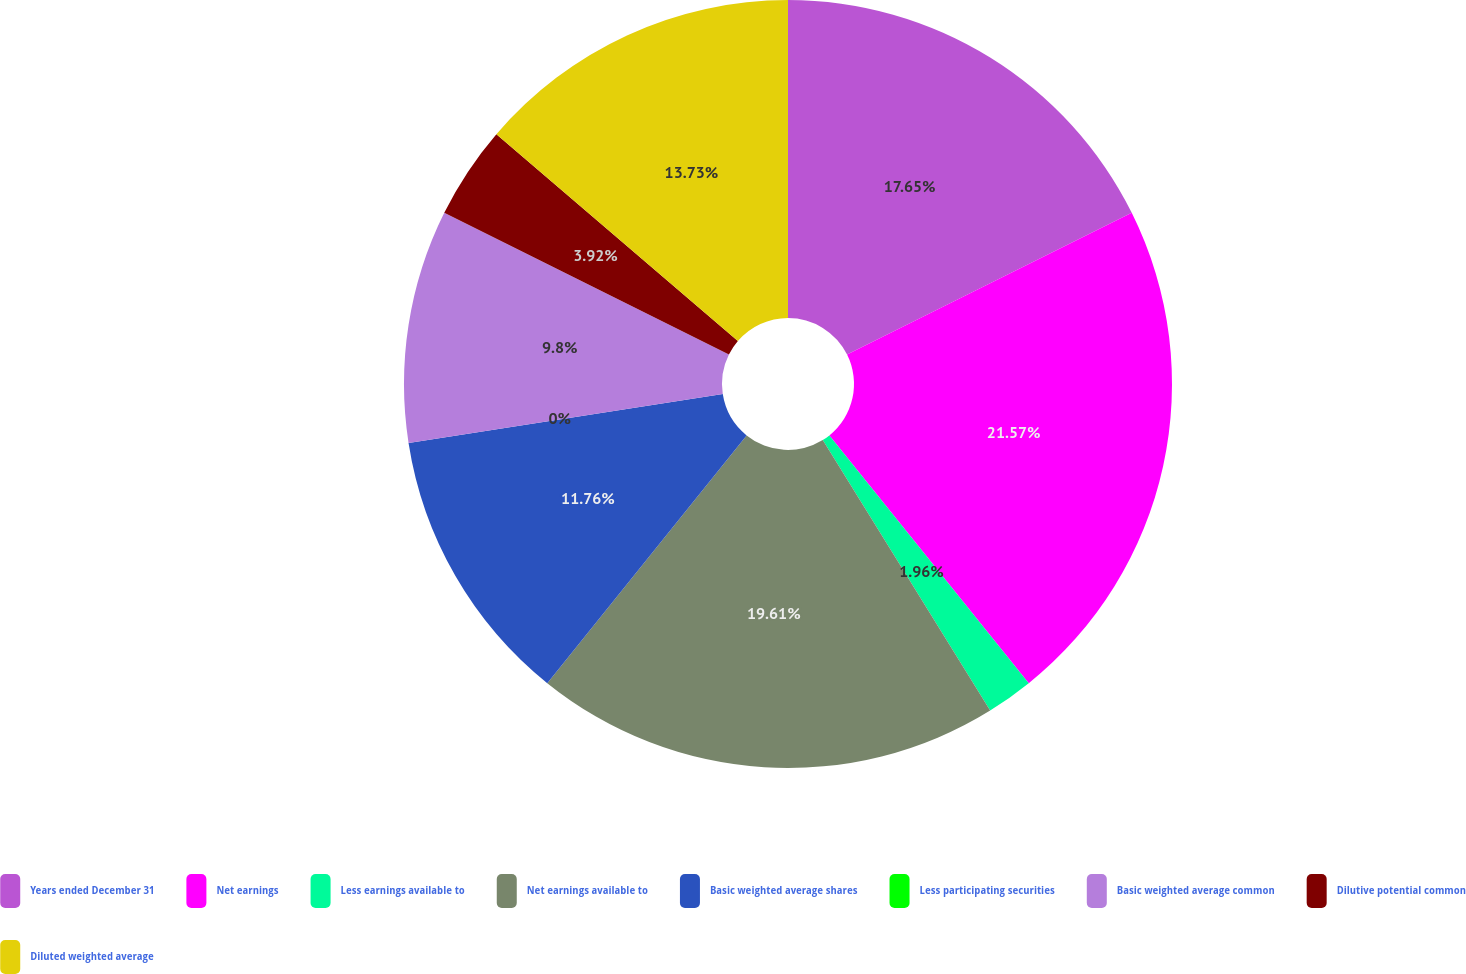Convert chart. <chart><loc_0><loc_0><loc_500><loc_500><pie_chart><fcel>Years ended December 31<fcel>Net earnings<fcel>Less earnings available to<fcel>Net earnings available to<fcel>Basic weighted average shares<fcel>Less participating securities<fcel>Basic weighted average common<fcel>Dilutive potential common<fcel>Diluted weighted average<nl><fcel>17.64%<fcel>21.56%<fcel>1.96%<fcel>19.6%<fcel>11.76%<fcel>0.0%<fcel>9.8%<fcel>3.92%<fcel>13.72%<nl></chart> 